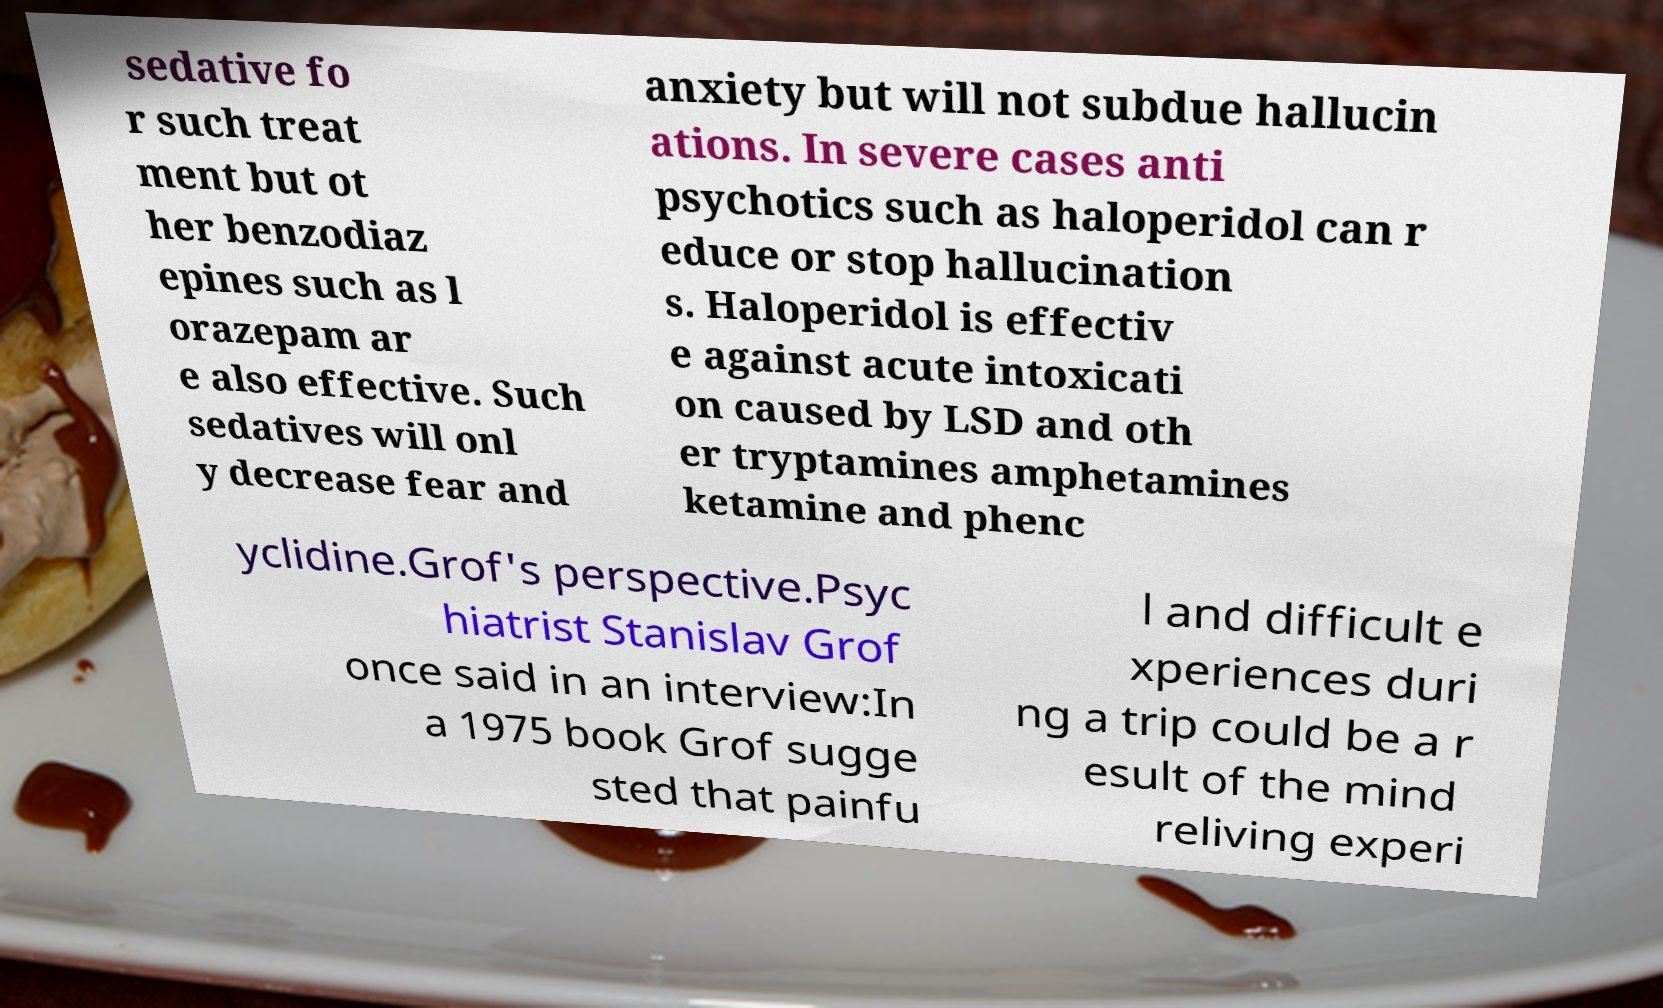For documentation purposes, I need the text within this image transcribed. Could you provide that? sedative fo r such treat ment but ot her benzodiaz epines such as l orazepam ar e also effective. Such sedatives will onl y decrease fear and anxiety but will not subdue hallucin ations. In severe cases anti psychotics such as haloperidol can r educe or stop hallucination s. Haloperidol is effectiv e against acute intoxicati on caused by LSD and oth er tryptamines amphetamines ketamine and phenc yclidine.Grof's perspective.Psyc hiatrist Stanislav Grof once said in an interview:In a 1975 book Grof sugge sted that painfu l and difficult e xperiences duri ng a trip could be a r esult of the mind reliving experi 